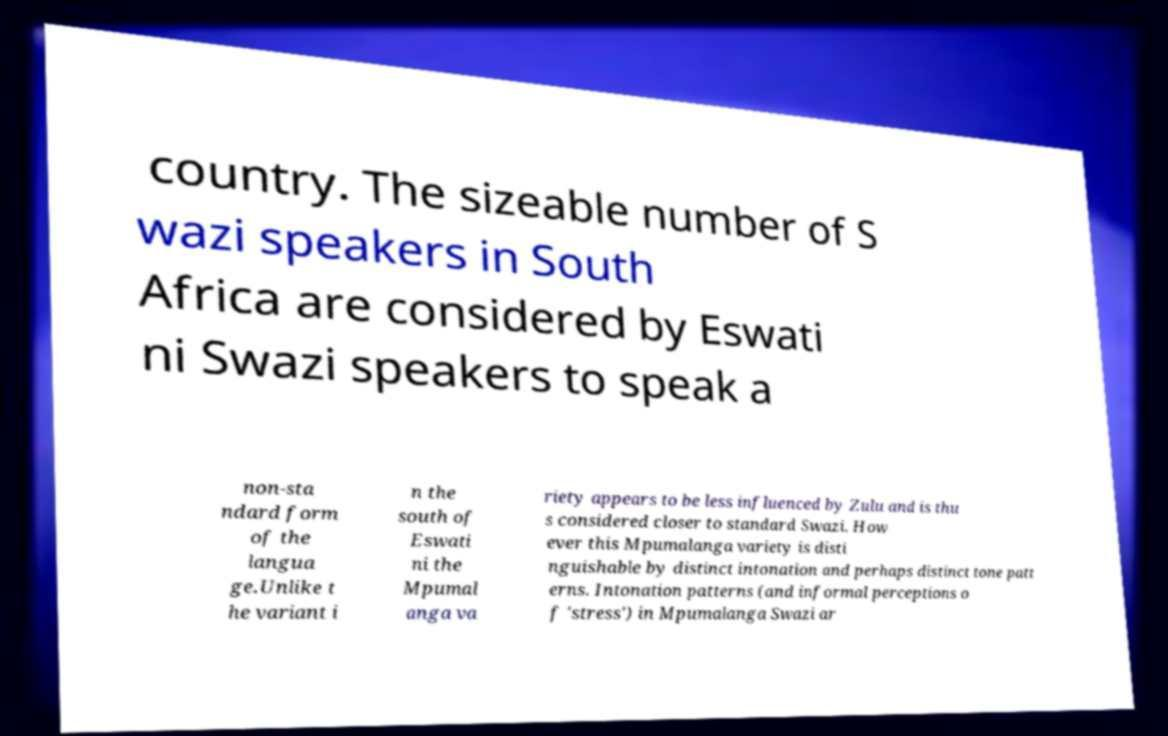I need the written content from this picture converted into text. Can you do that? country. The sizeable number of S wazi speakers in South Africa are considered by Eswati ni Swazi speakers to speak a non-sta ndard form of the langua ge.Unlike t he variant i n the south of Eswati ni the Mpumal anga va riety appears to be less influenced by Zulu and is thu s considered closer to standard Swazi. How ever this Mpumalanga variety is disti nguishable by distinct intonation and perhaps distinct tone patt erns. Intonation patterns (and informal perceptions o f 'stress') in Mpumalanga Swazi ar 